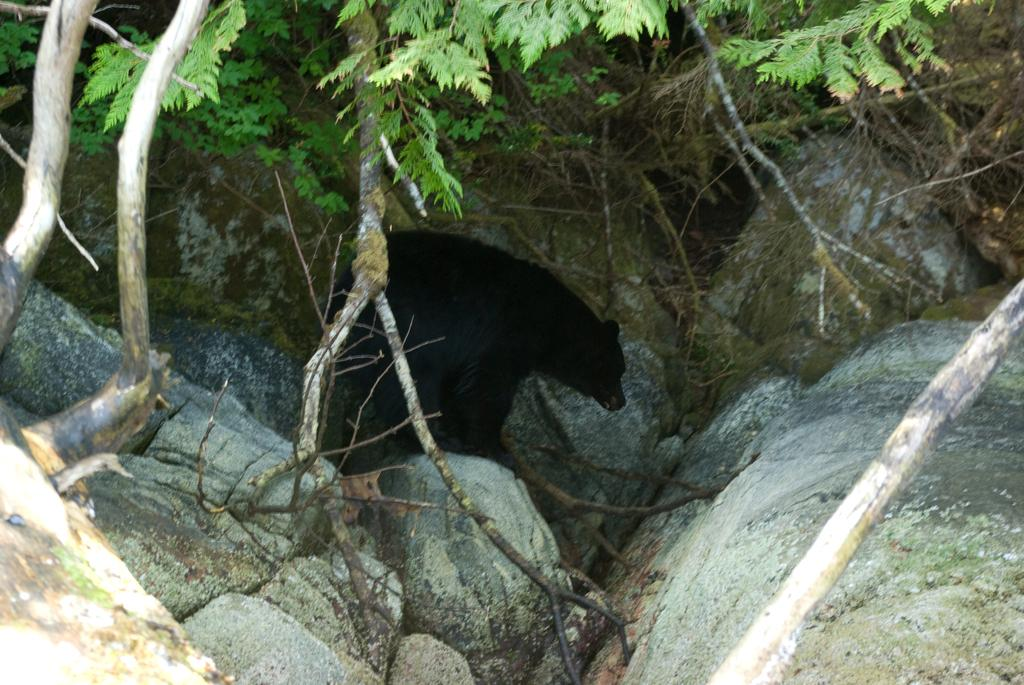What is the main subject of the image? There are many rocks in the image. Is there any wildlife visible among the rocks? Yes, there is a black bear among the rocks. What can be seen above the bear in the image? There are branches of trees above the bear. How many boys are using a rake to gather leaves in the image? There are no boys or rakes present in the image; it features rocks and a black bear. What type of pot is visible on the ground near the bear? There is no pot visible in the image; it only contains rocks and a black bear. 